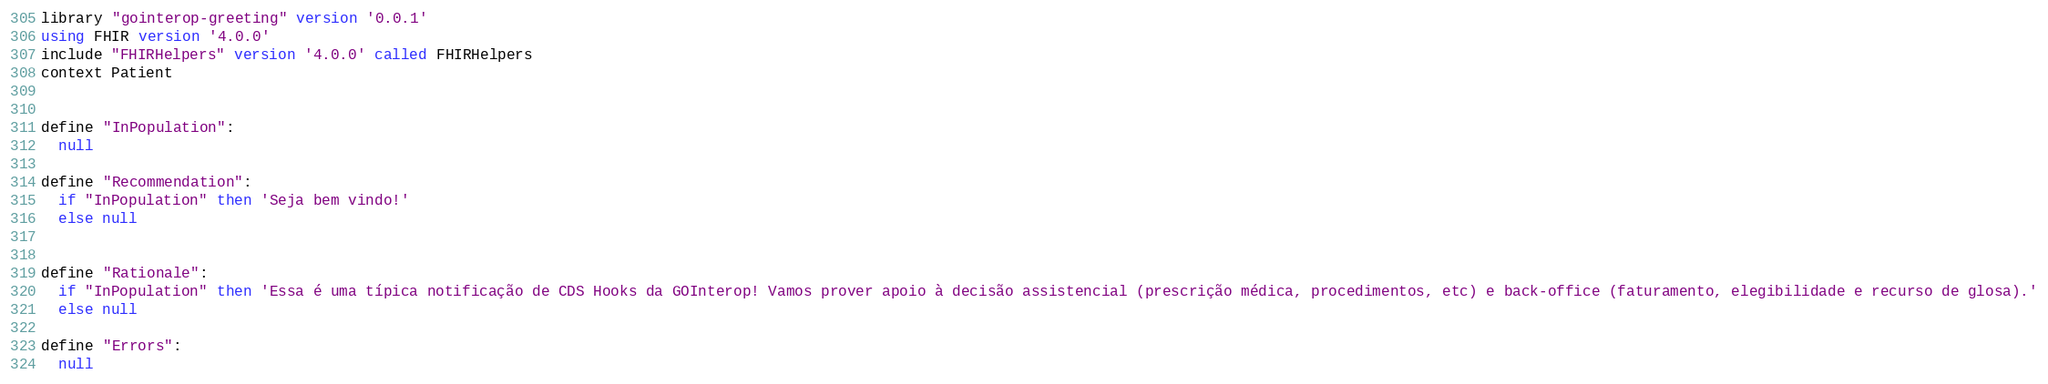<code> <loc_0><loc_0><loc_500><loc_500><_SQL_>library "gointerop-greeting" version '0.0.1'
using FHIR version '4.0.0'
include "FHIRHelpers" version '4.0.0' called FHIRHelpers 
context Patient


define "InPopulation":
  null

define "Recommendation": 
  if "InPopulation" then 'Seja bem vindo!'
  else null
  

define "Rationale":
  if "InPopulation" then 'Essa é uma típica notificação de CDS Hooks da GOInterop! Vamos prover apoio à decisão assistencial (prescrição médica, procedimentos, etc) e back-office (faturamento, elegibilidade e recurso de glosa).'
  else null

define "Errors":
  null

</code> 